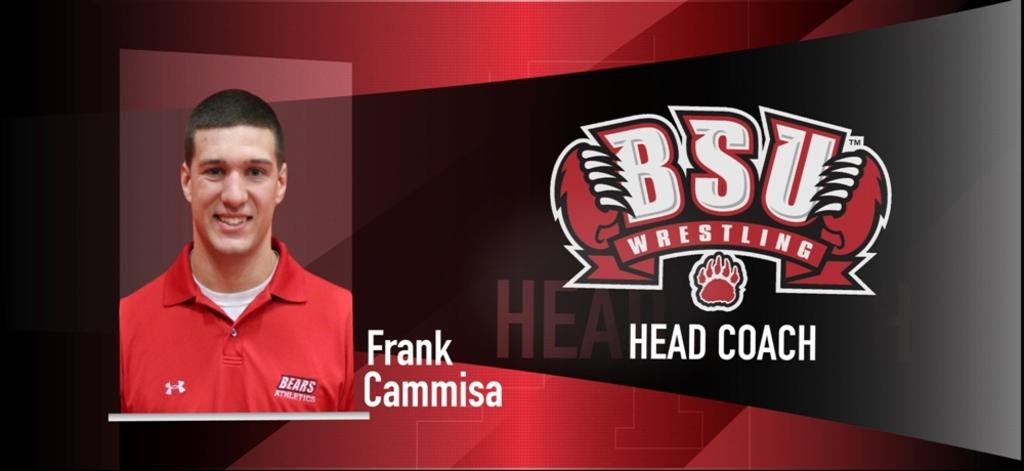<image>
Create a compact narrative representing the image presented. BSU Wrestling's head coach smiles in his headshot. 